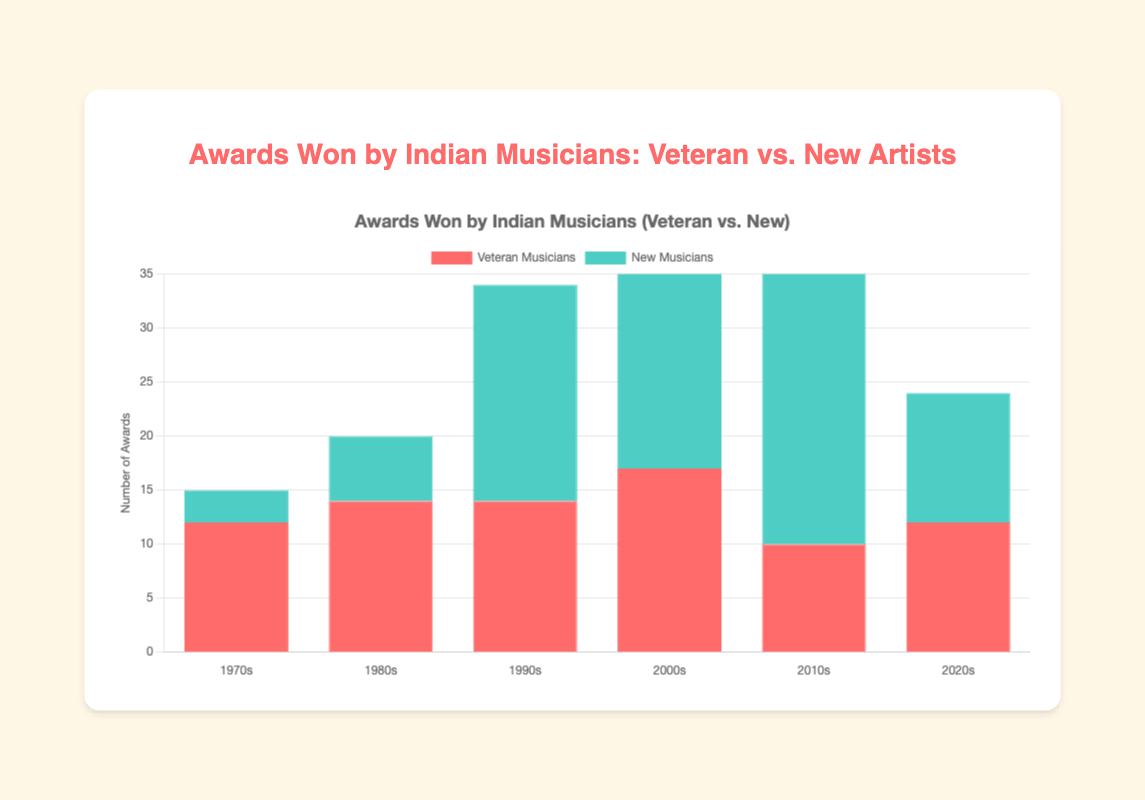Which decade saw the highest total number of awards won by musicians? To determine the decade with the highest total number of awards, we add the awards won by veteran and new musicians in each decade and compare them. The totals are: 1970s (15), 1980s (20), 1990s (34), 2000s (43), 2010s (40), 2020s (24).
Answer: 2000s Who won more awards in the 2010s, veteran musicians or new musicians? Sum the awards won by veteran musicians (Hariharan 3 + S. P. Balasubrahmanyam 5 + Lata Mangeshkar 2 = 10) and compare it with new musicians (Arijit Singh 15 + Neha Kakkar 8 + Armaan Malik 7 = 30).
Answer: New musicians Which individual musician had the highest number of awards in any decade? Compare the highest individual awards for each decade: 1970s (Lata Mangeshkar 5), 1980s (Lata Mangeshkar 6), 1990s (Udit Narayan 8), 2000s (Sonu Nigam 10), 2010s (Arijit Singh 15), 2020s (Armaan Malik 6).
Answer: Arijit Singh For the 1990s, what is the difference between the total awards for new musicians and veteran musicians? Calculate the total awards for new musicians (Udit Narayan 8 + Alka Yagnik 7 + K. S. Chithra 5 = 20) and veteran musicians (Asha Bhosle 6 + Jagjit Singh 5 + Kumar Sanu 3 = 14), then find the difference (20 - 14).
Answer: 6 How did the number of awards won by veteran musicians change from the 1970s to the 1980s? Summarize the awards for veteran musicians: 1970s (Lata Mangeshkar 5 + Kishore Kumar 4 + M.S. Subbulakshmi 3 = 12), 1980s (Lata Mangeshkar 6 + Kishore Kumar 3 + Asha Bhosle 5 = 14), and calculate the change (14 - 12).
Answer: Increased by 2 Which decade had the smallest difference in awards between veteran and new musicians? Calculate the difference in awards for each decade: 1970s (Veteran 12 - New 3 = 9), 1980s (Veteran 14 - New 6 = 8), 1990s (Veteran 14 - New 20 = 6), 2000s (Veteran 17 - New 26 = 9), 2010s (Veteran 10 - New 30 = 20), 2020s (Veteran 12 - New 12 = 0).
Answer: 2020s Who won more awards in the 1980s, Asha Bhosle or Lata Mangeshkar? Compare the awards for Asha Bhosle (5) and Lata Mangeshkar (6).
Answer: Lata Mangeshkar Which color corresponds to new musicians in the bar chart? The background colors for the bar chart are Red for veteran musicians and Green for new musicians, according to the coded dataset description.
Answer: Green From the 2000s to the 2010s, how did the total number of awards for new musicians change? Calculate the total awards for new musicians in the 2000s (Sonu Nigam 10 + Shreya Ghoshal 9 + Sunidhi Chauhan 7 = 26) and for the 2010s (Arijit Singh 15 + Neha Kakkar 8 + Armaan Malik 7 = 30), and find the change (30 - 26).
Answer: Increased by 4 